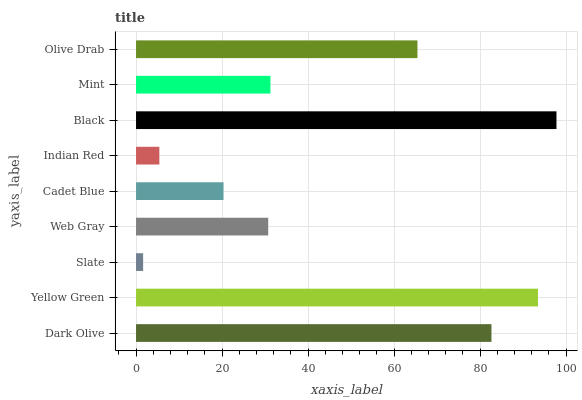Is Slate the minimum?
Answer yes or no. Yes. Is Black the maximum?
Answer yes or no. Yes. Is Yellow Green the minimum?
Answer yes or no. No. Is Yellow Green the maximum?
Answer yes or no. No. Is Yellow Green greater than Dark Olive?
Answer yes or no. Yes. Is Dark Olive less than Yellow Green?
Answer yes or no. Yes. Is Dark Olive greater than Yellow Green?
Answer yes or no. No. Is Yellow Green less than Dark Olive?
Answer yes or no. No. Is Mint the high median?
Answer yes or no. Yes. Is Mint the low median?
Answer yes or no. Yes. Is Slate the high median?
Answer yes or no. No. Is Indian Red the low median?
Answer yes or no. No. 